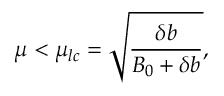<formula> <loc_0><loc_0><loc_500><loc_500>\mu < \mu _ { l c } = \sqrt { \frac { \delta b } { B _ { 0 } + \delta b } } ,</formula> 